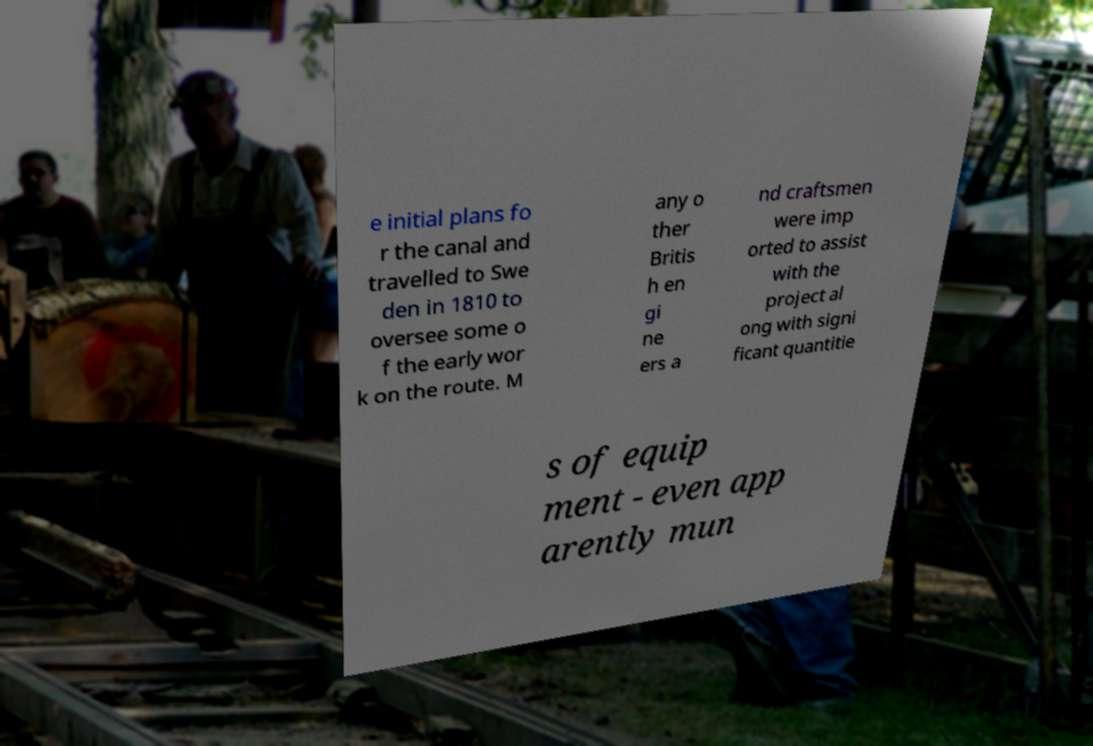Please read and relay the text visible in this image. What does it say? e initial plans fo r the canal and travelled to Swe den in 1810 to oversee some o f the early wor k on the route. M any o ther Britis h en gi ne ers a nd craftsmen were imp orted to assist with the project al ong with signi ficant quantitie s of equip ment - even app arently mun 